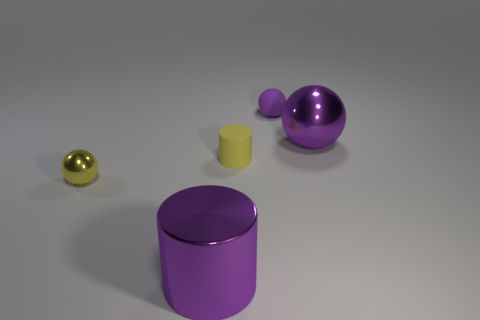Is the number of yellow things in front of the small shiny object the same as the number of metal balls that are left of the big purple shiny cylinder?
Provide a short and direct response. No. How many other objects are the same color as the large metallic cylinder?
Your answer should be compact. 2. Are there the same number of small cylinders that are in front of the matte cylinder and tiny red cylinders?
Ensure brevity in your answer.  Yes. Do the yellow matte cylinder and the purple matte thing have the same size?
Make the answer very short. Yes. What is the ball that is both in front of the purple matte thing and on the left side of the big metallic ball made of?
Make the answer very short. Metal. How many other small rubber things are the same shape as the small purple object?
Provide a short and direct response. 0. There is a small yellow object that is on the left side of the big purple cylinder; what material is it?
Your answer should be compact. Metal. Are there fewer yellow rubber cylinders that are to the right of the small yellow rubber thing than small brown objects?
Provide a short and direct response. No. Do the small purple matte thing and the tiny metallic thing have the same shape?
Provide a short and direct response. Yes. Are any red rubber spheres visible?
Offer a terse response. No. 